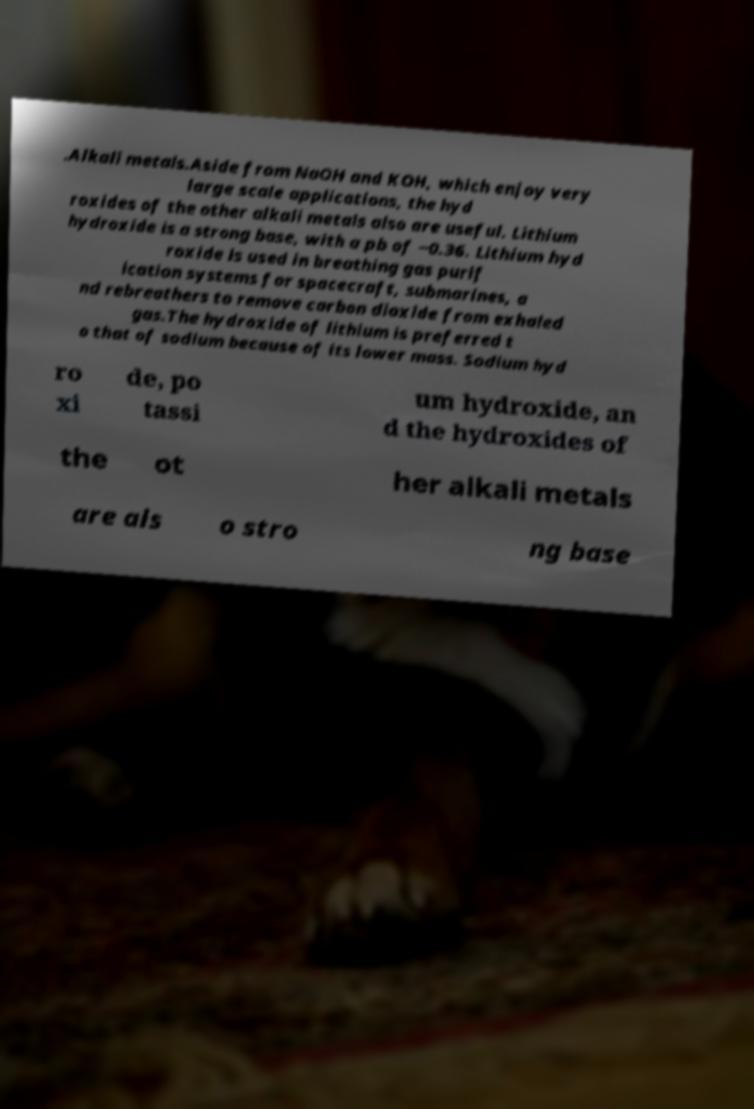For documentation purposes, I need the text within this image transcribed. Could you provide that? .Alkali metals.Aside from NaOH and KOH, which enjoy very large scale applications, the hyd roxides of the other alkali metals also are useful. Lithium hydroxide is a strong base, with a pb of −0.36. Lithium hyd roxide is used in breathing gas purif ication systems for spacecraft, submarines, a nd rebreathers to remove carbon dioxide from exhaled gas.The hydroxide of lithium is preferred t o that of sodium because of its lower mass. Sodium hyd ro xi de, po tassi um hydroxide, an d the hydroxides of the ot her alkali metals are als o stro ng base 